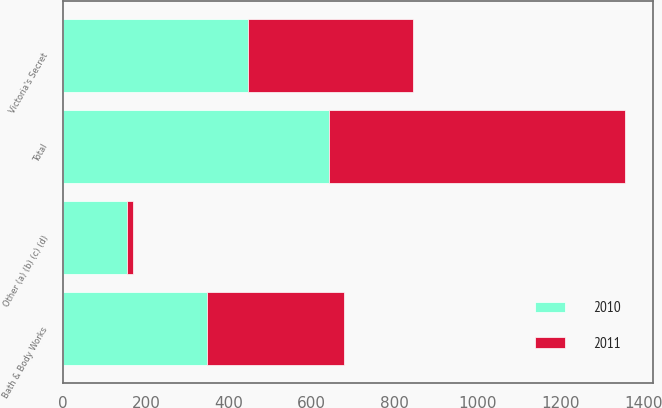Convert chart to OTSL. <chart><loc_0><loc_0><loc_500><loc_500><stacked_bar_chart><ecel><fcel>Victoria's Secret<fcel>Bath & Body Works<fcel>Other (a) (b) (c) (d)<fcel>Total<nl><fcel>2010<fcel>447<fcel>348<fcel>154<fcel>641<nl><fcel>2011<fcel>398<fcel>330<fcel>14<fcel>714<nl></chart> 